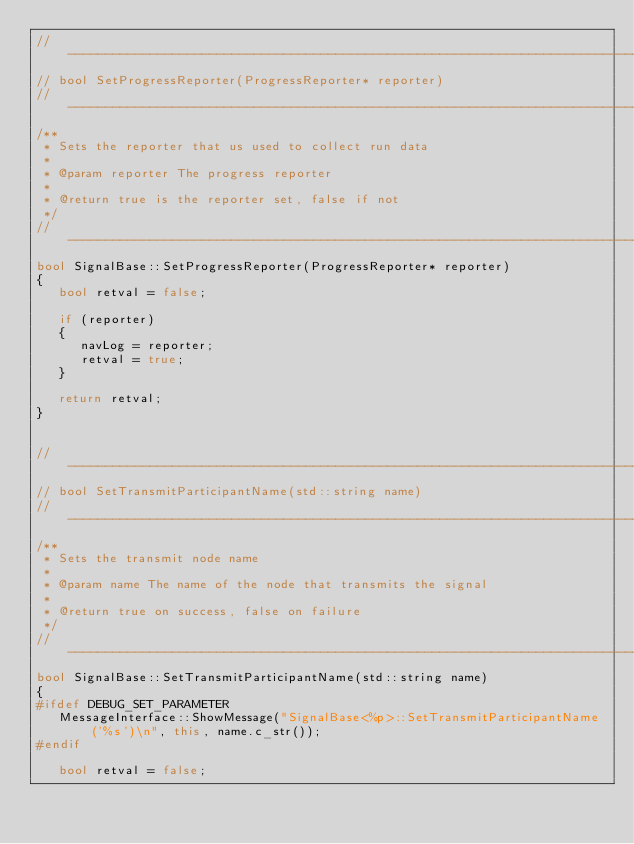Convert code to text. <code><loc_0><loc_0><loc_500><loc_500><_C++_>//------------------------------------------------------------------------------
// bool SetProgressReporter(ProgressReporter* reporter)
//------------------------------------------------------------------------------
/**
 * Sets the reporter that us used to collect run data
 *
 * @param reporter The progress reporter
 *
 * @return true is the reporter set, false if not
 */
//------------------------------------------------------------------------------
bool SignalBase::SetProgressReporter(ProgressReporter* reporter)
{
   bool retval = false;

   if (reporter)
   {
      navLog = reporter;
      retval = true;
   }

   return retval;
}


//------------------------------------------------------------------------------
// bool SetTransmitParticipantName(std::string name)
//------------------------------------------------------------------------------
/**
 * Sets the transmit node name
 *
 * @param name The name of the node that transmits the signal
 *
 * @return true on success, false on failure
 */
//------------------------------------------------------------------------------
bool SignalBase::SetTransmitParticipantName(std::string name)
{
#ifdef DEBUG_SET_PARAMETER
   MessageInterface::ShowMessage("SignalBase<%p>::SetTransmitParticipantName('%s')\n", this, name.c_str());
#endif

   bool retval = false;</code> 